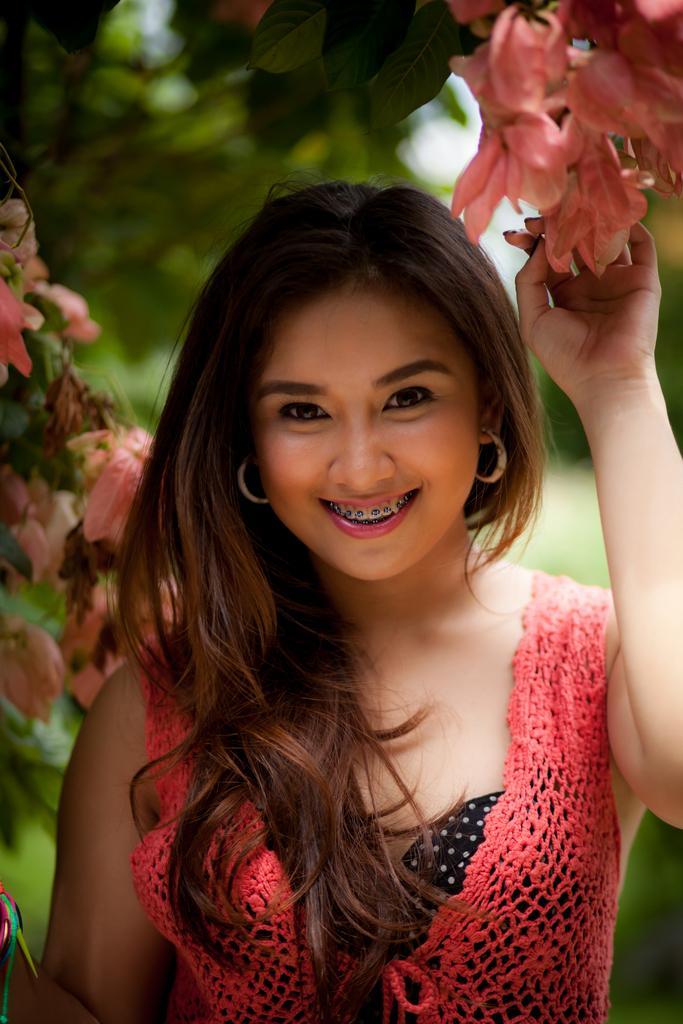Could you give a brief overview of what you see in this image? In the picture I can see one girl is standing and holding the flowers and smiling by looking straight and back side of the image is blurred. 